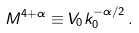<formula> <loc_0><loc_0><loc_500><loc_500>M ^ { 4 + \alpha } \equiv V _ { 0 } k ^ { - \alpha / 2 } _ { 0 } \, .</formula> 